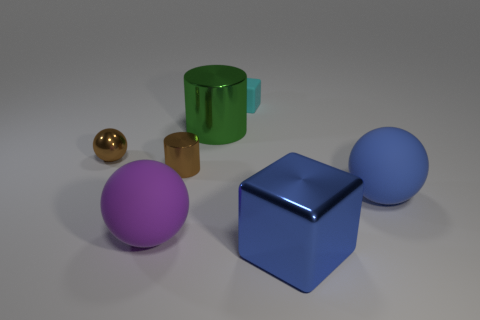Add 2 blue rubber things. How many objects exist? 9 Subtract all cyan blocks. How many blocks are left? 1 Subtract all shiny spheres. How many spheres are left? 2 Subtract all balls. How many objects are left? 4 Add 5 large blue rubber spheres. How many large blue rubber spheres are left? 6 Add 7 shiny cylinders. How many shiny cylinders exist? 9 Subtract 1 purple spheres. How many objects are left? 6 Subtract 2 spheres. How many spheres are left? 1 Subtract all brown balls. Subtract all red cubes. How many balls are left? 2 Subtract all yellow spheres. How many green cylinders are left? 1 